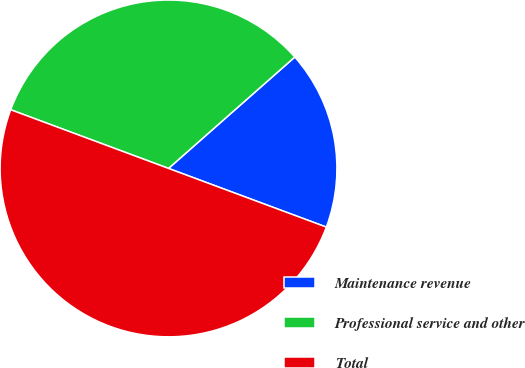<chart> <loc_0><loc_0><loc_500><loc_500><pie_chart><fcel>Maintenance revenue<fcel>Professional service and other<fcel>Total<nl><fcel>17.17%<fcel>32.83%<fcel>50.0%<nl></chart> 